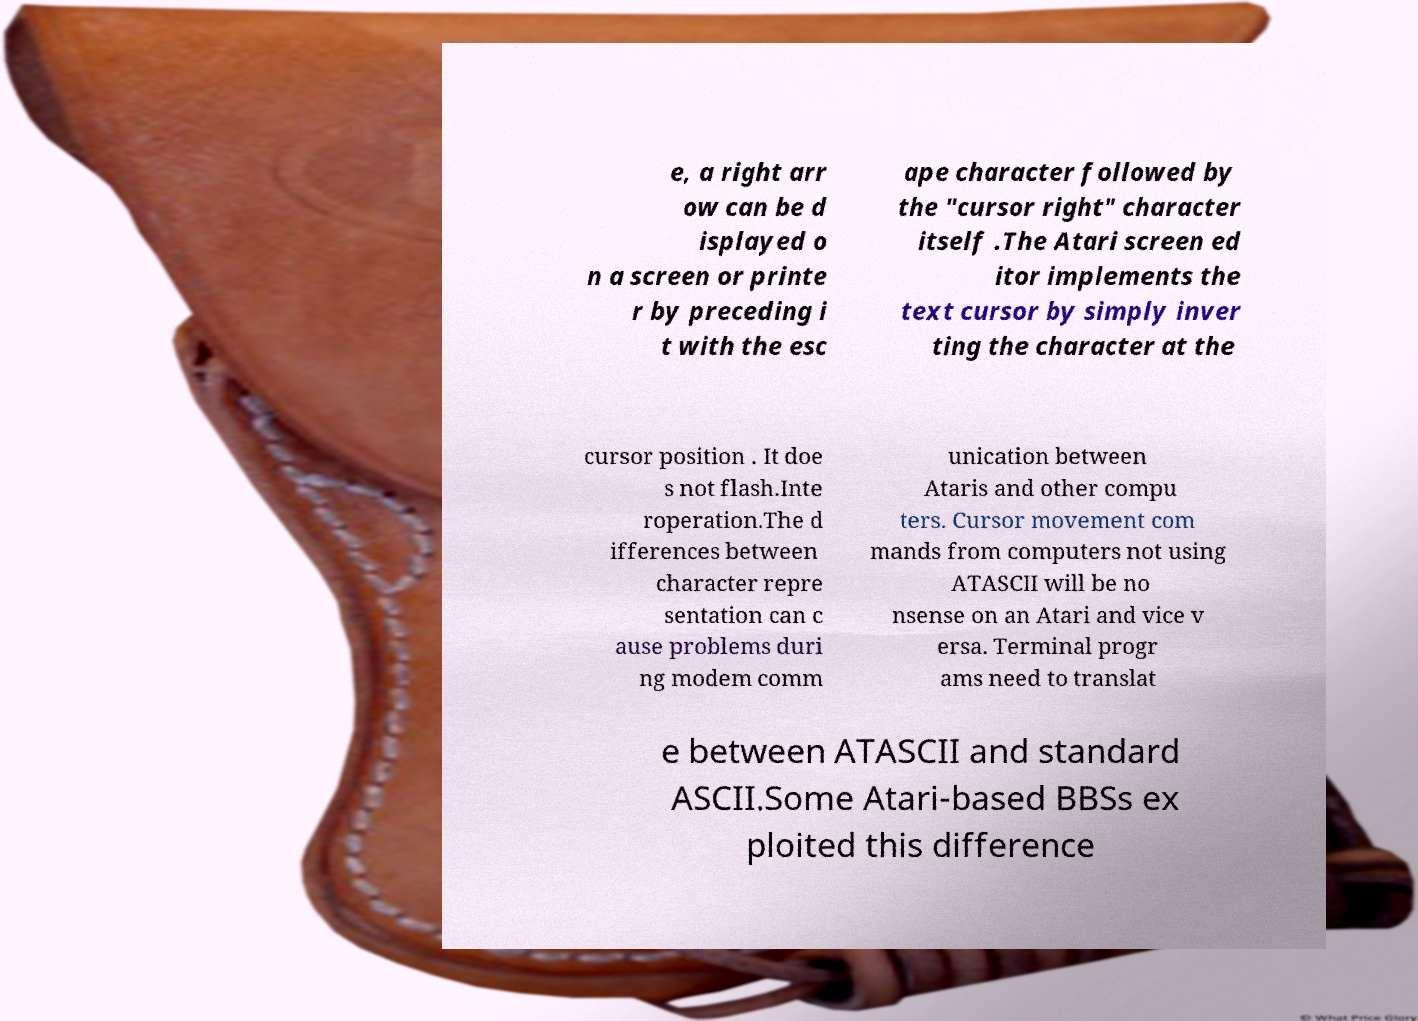What messages or text are displayed in this image? I need them in a readable, typed format. e, a right arr ow can be d isplayed o n a screen or printe r by preceding i t with the esc ape character followed by the "cursor right" character itself .The Atari screen ed itor implements the text cursor by simply inver ting the character at the cursor position . It doe s not flash.Inte roperation.The d ifferences between character repre sentation can c ause problems duri ng modem comm unication between Ataris and other compu ters. Cursor movement com mands from computers not using ATASCII will be no nsense on an Atari and vice v ersa. Terminal progr ams need to translat e between ATASCII and standard ASCII.Some Atari-based BBSs ex ploited this difference 